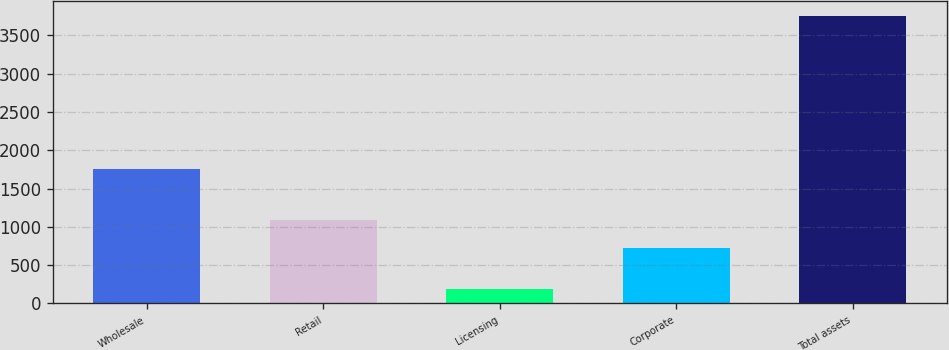Convert chart to OTSL. <chart><loc_0><loc_0><loc_500><loc_500><bar_chart><fcel>Wholesale<fcel>Retail<fcel>Licensing<fcel>Corporate<fcel>Total assets<nl><fcel>1756<fcel>1084.7<fcel>190.2<fcel>727.1<fcel>3758<nl></chart> 